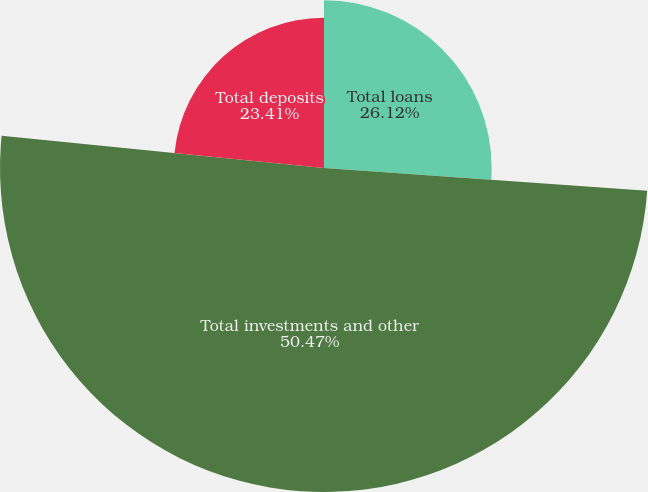Convert chart to OTSL. <chart><loc_0><loc_0><loc_500><loc_500><pie_chart><fcel>Total loans<fcel>Total investments and other<fcel>Total deposits<nl><fcel>26.12%<fcel>50.48%<fcel>23.41%<nl></chart> 